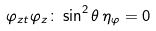<formula> <loc_0><loc_0><loc_500><loc_500>\varphi _ { z t } \varphi _ { z } \colon \sin ^ { 2 } \theta \, \eta _ { \varphi } = 0</formula> 